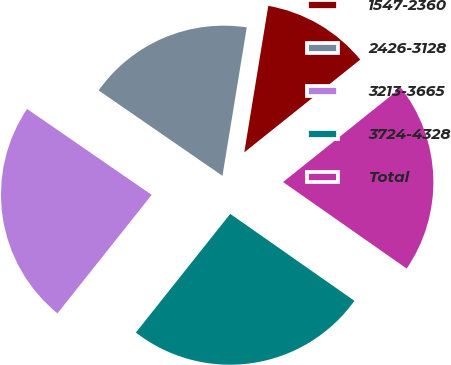<chart> <loc_0><loc_0><loc_500><loc_500><pie_chart><fcel>1547-2360<fcel>2426-3128<fcel>3213-3665<fcel>3724-4328<fcel>Total<nl><fcel>11.68%<fcel>17.97%<fcel>23.92%<fcel>25.97%<fcel>20.46%<nl></chart> 